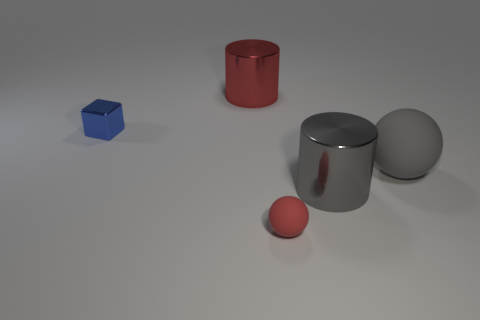Add 2 green rubber things. How many objects exist? 7 Subtract all green cubes. Subtract all blue cylinders. How many cubes are left? 1 Subtract all blocks. Subtract all blue objects. How many objects are left? 3 Add 2 large red metal things. How many large red metal things are left? 3 Add 5 gray metal cylinders. How many gray metal cylinders exist? 6 Subtract 0 green cylinders. How many objects are left? 5 Subtract all cylinders. How many objects are left? 3 Subtract 1 cylinders. How many cylinders are left? 1 